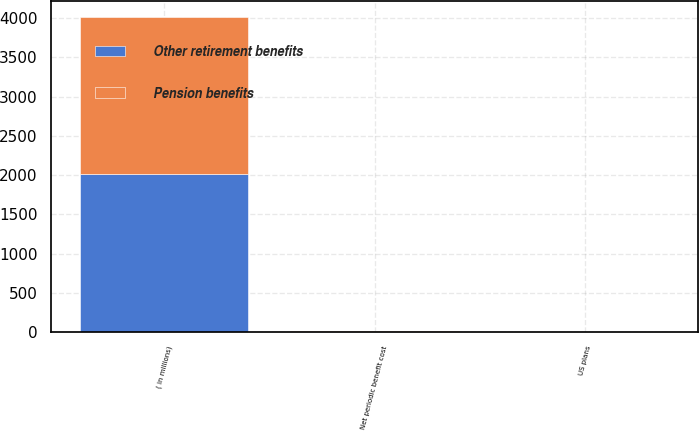<chart> <loc_0><loc_0><loc_500><loc_500><stacked_bar_chart><ecel><fcel>( in millions)<fcel>US plans<fcel>Net periodic benefit cost<nl><fcel>Other retirement benefits<fcel>2008<fcel>4.3<fcel>5.9<nl><fcel>Pension benefits<fcel>2008<fcel>1.7<fcel>1.7<nl></chart> 